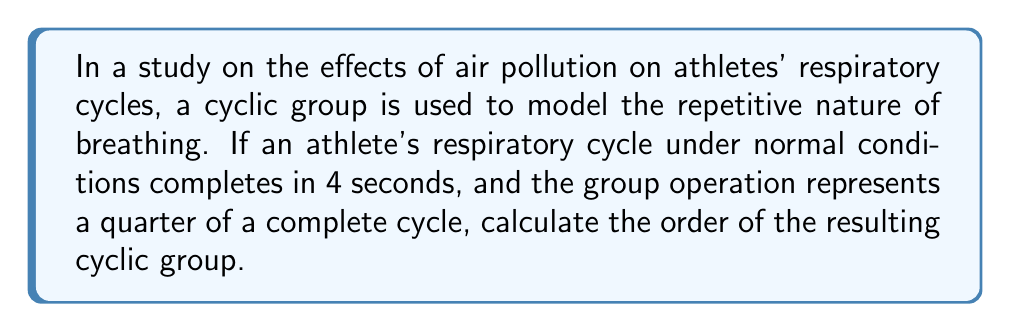Can you answer this question? To solve this problem, we need to understand the relationship between the respiratory cycle and the cyclic group:

1. The complete respiratory cycle takes 4 seconds.
2. The group operation represents a quarter (1/4) of a complete cycle.

To find the order of the cyclic group, we need to determine how many times we need to apply the group operation to return to the starting point (identity element).

Let's denote the group operation as $g$. Then:

$g$ = 1/4 of a cycle = 1 second
$g^2$ = 1/2 of a cycle = 2 seconds
$g^3$ = 3/4 of a cycle = 3 seconds
$g^4$ = 1 complete cycle = 4 seconds (back to the starting point)

Therefore, it takes 4 applications of the group operation to complete one full cycle and return to the identity element.

In abstract algebra, the order of a cyclic group is the smallest positive integer $n$ such that $g^n = e$, where $e$ is the identity element.

In this case, $n = 4$.

Thus, the cyclic group representing the respiratory cycles has an order of 4.

This can be written as:

$$|G| = 4$$

where $|G|$ denotes the order of the group $G$.

The resulting cyclic group is isomorphic to $\mathbb{Z}_4$, the group of integers modulo 4 under addition.
Answer: The order of the cyclic group representing respiratory cycles is 4. 